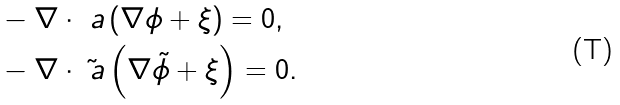<formula> <loc_0><loc_0><loc_500><loc_500>& - \nabla \cdot \ a \left ( \nabla \phi + \xi \right ) = 0 , \\ & - \nabla \cdot \tilde { \ a } \left ( \nabla \tilde { \phi } + \xi \right ) = 0 .</formula> 